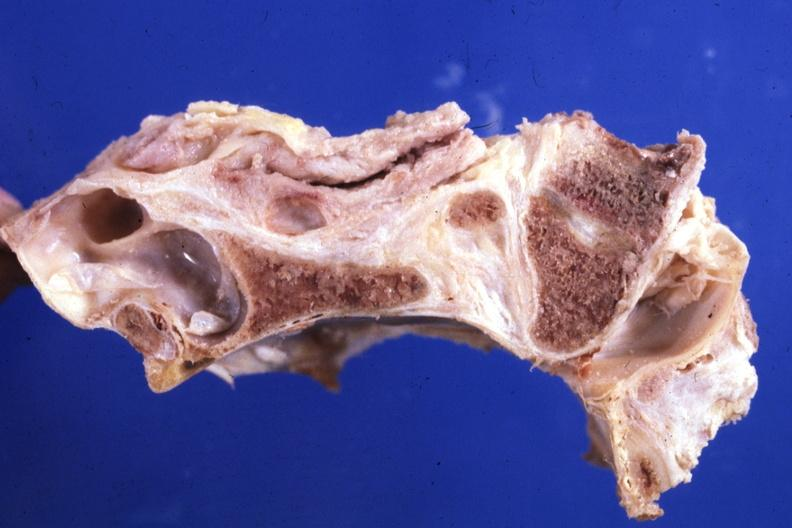s chromophobe adenoma present?
Answer the question using a single word or phrase. No 